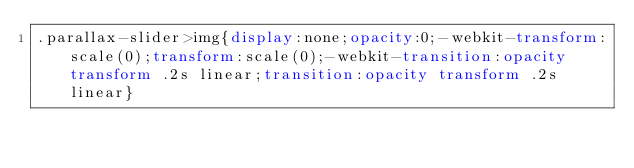<code> <loc_0><loc_0><loc_500><loc_500><_CSS_>.parallax-slider>img{display:none;opacity:0;-webkit-transform:scale(0);transform:scale(0);-webkit-transition:opacity transform .2s linear;transition:opacity transform .2s linear}</code> 